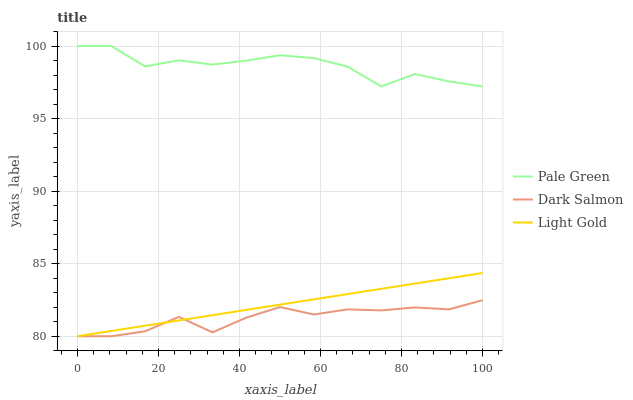Does Dark Salmon have the minimum area under the curve?
Answer yes or no. Yes. Does Pale Green have the maximum area under the curve?
Answer yes or no. Yes. Does Light Gold have the minimum area under the curve?
Answer yes or no. No. Does Light Gold have the maximum area under the curve?
Answer yes or no. No. Is Light Gold the smoothest?
Answer yes or no. Yes. Is Pale Green the roughest?
Answer yes or no. Yes. Is Dark Salmon the smoothest?
Answer yes or no. No. Is Dark Salmon the roughest?
Answer yes or no. No. Does Light Gold have the lowest value?
Answer yes or no. Yes. Does Pale Green have the highest value?
Answer yes or no. Yes. Does Light Gold have the highest value?
Answer yes or no. No. Is Dark Salmon less than Pale Green?
Answer yes or no. Yes. Is Pale Green greater than Light Gold?
Answer yes or no. Yes. Does Dark Salmon intersect Light Gold?
Answer yes or no. Yes. Is Dark Salmon less than Light Gold?
Answer yes or no. No. Is Dark Salmon greater than Light Gold?
Answer yes or no. No. Does Dark Salmon intersect Pale Green?
Answer yes or no. No. 